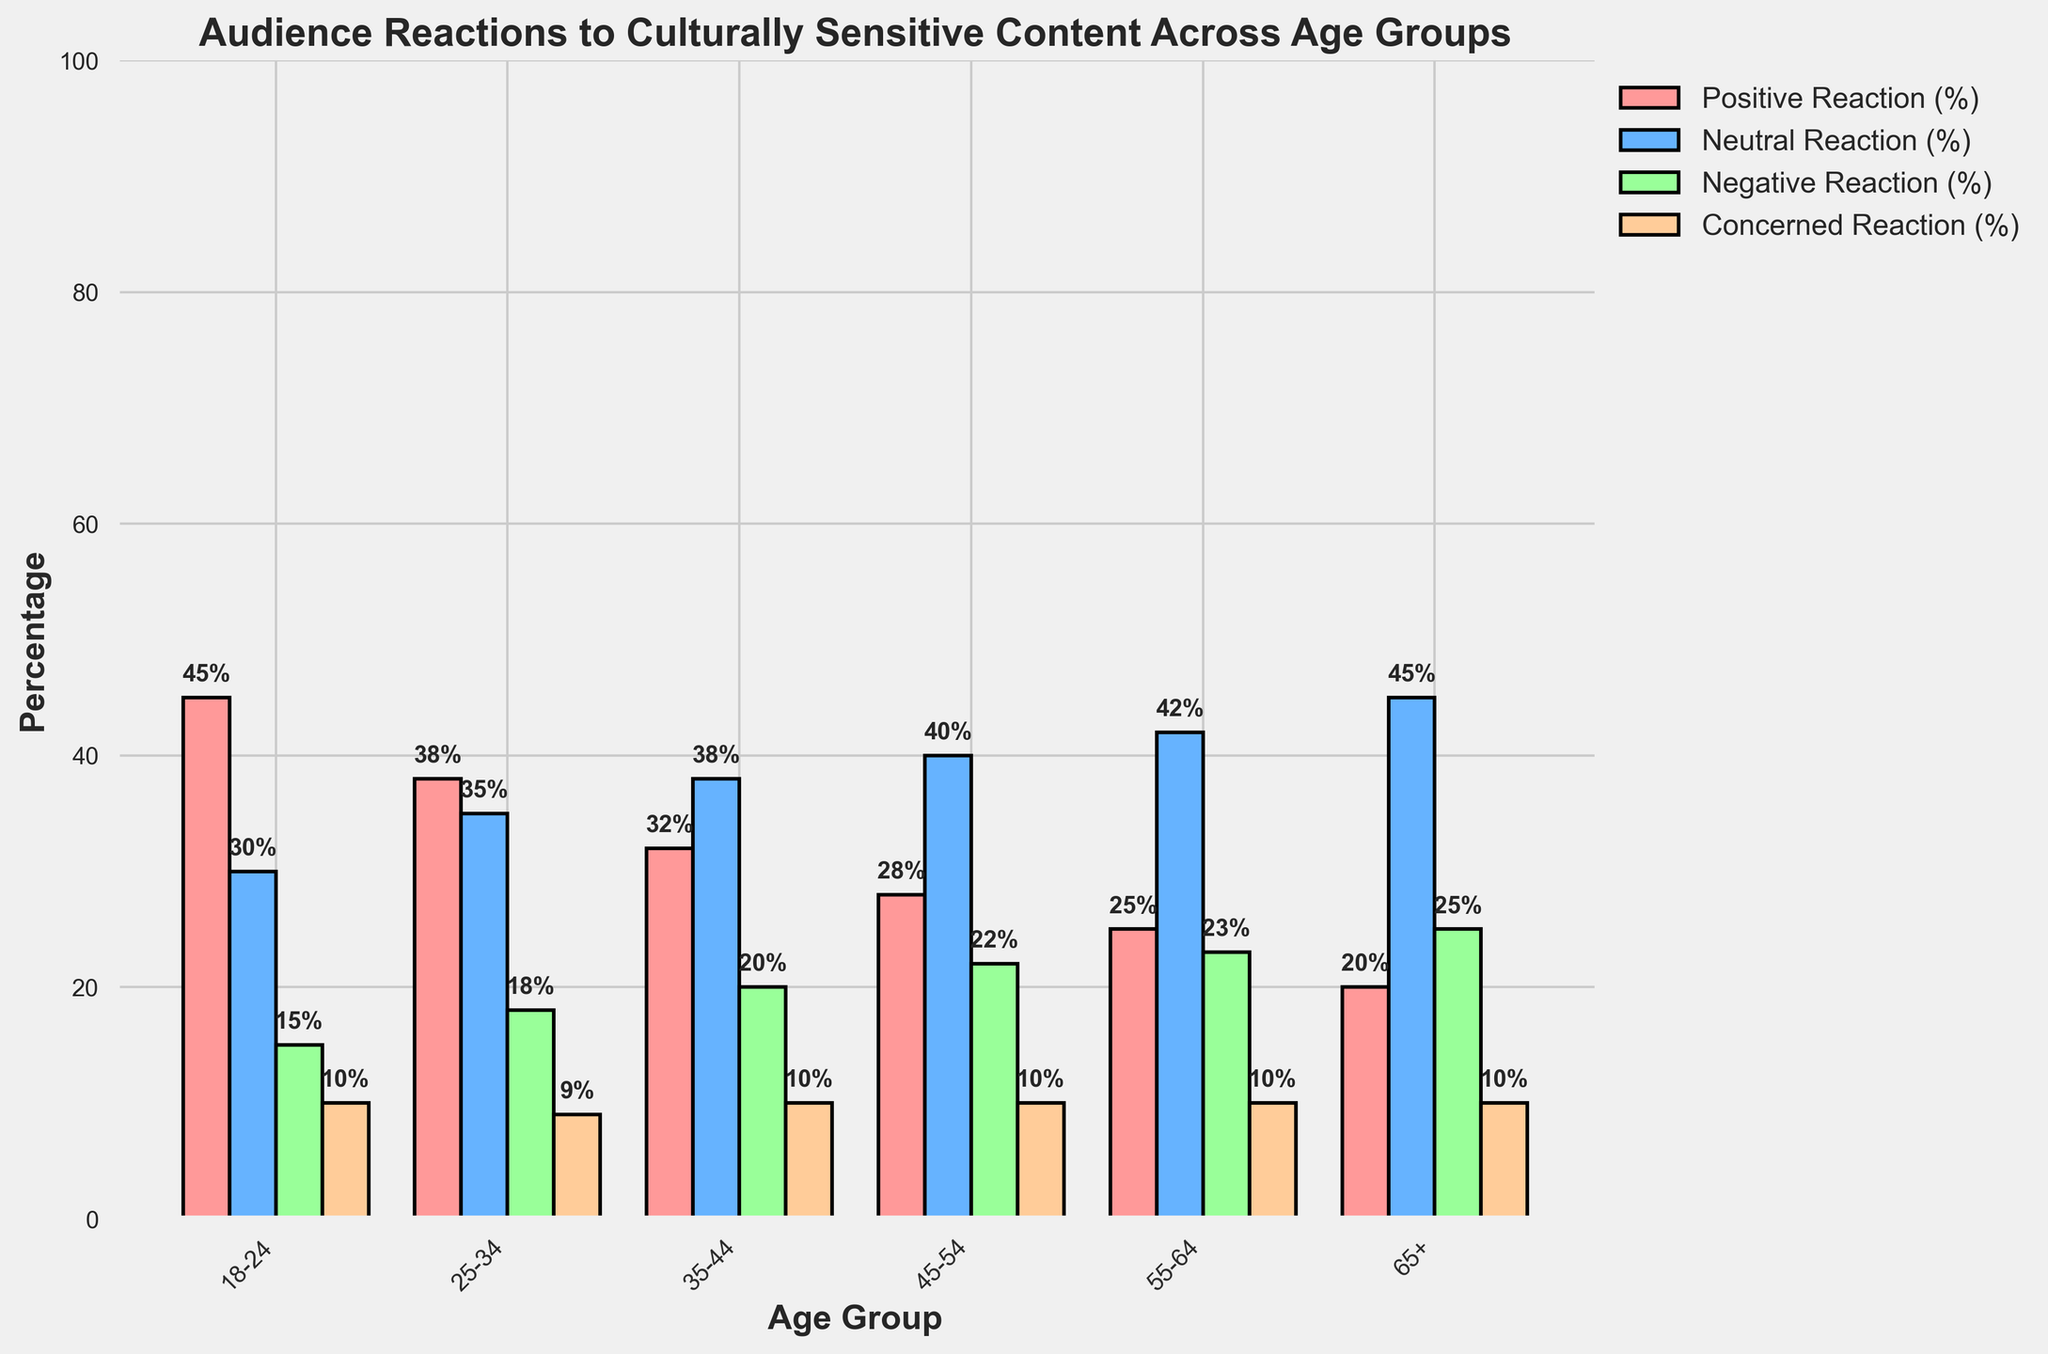Which age group has the highest percentage of positive reactions? Compare the height of the bars representing positive reactions across all age groups. The highest bar indicates the age group 18-24 has the highest at 45%.
Answer: 18-24 What is the total percentage of neutral reactions for ages 25-34 and 35-44? Sum up the percentage of neutral reactions for the age groups 25-34 (35%) and 35-44 (38%). Thus, 35% + 38% = 73%.
Answer: 73% Between ages 45-54 and 55-64, which group has a higher percentage of negative reactions? Compare the heights of the bars representing negative reactions for the age groups 45-54 (22%) and 55-64 (23%). The higher bar shows that 55-64 has a higher percentage.
Answer: 55-64 Is the concerned reaction percentage constant across all age groups? Observe the heights of the concerned reaction bars across all age groups, which are all equal at 10%.
Answer: Yes What is the difference in positive reactions between the youngest and the oldest age groups? Subtract the positive reaction percentage of age group 65+ (20%) from the positive reaction percentage of age group 18-24 (45%). The difference is 45% - 20% = 25%.
Answer: 25% How does the neutral reaction percentage change as age increases? Compare the heights of the neutral reaction bars from the youngest to the oldest age groups. The percentage increases from 30% to 45% as age increases.
Answer: Increases What is the average negative reaction percentage across all age groups? Add the negative reaction percentages for all age groups (15%, 18%, 20%, 22%, 23%, 25%) and then divide by the number of age groups (6). The sum is 123%, so 123% / 6 = 20.5%.
Answer: 20.5% Which age group shows the most significant concern for culturally sensitive content? Compare the heights of the concerned reaction bars across all age groups, which are all equal at 10%. Thus, no single group shows more concern than others.
Answer: None Between ages 25-34 and ages 35-44, which group has a higher overall positive and neutral reaction combined? Sum up the positive and neutral reactions for each group: 25-34 (38% + 35% = 73%) and 35-44 (32% + 38% = 70%). The group 25-34 has a higher combined reaction.
Answer: 25-34 What percentage of the age group 65+ has either a positive or neutral reaction? Sum the positive (20%) and neutral (45%) reaction percentages for the age group 65+. Thus, 20% + 45% = 65%.
Answer: 65% 